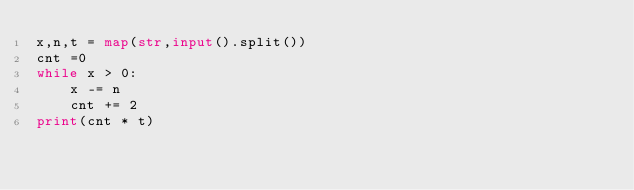<code> <loc_0><loc_0><loc_500><loc_500><_Python_>x,n,t = map(str,input().split())
cnt =0
while x > 0:
    x -= n
    cnt += 2
print(cnt * t)</code> 